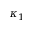<formula> <loc_0><loc_0><loc_500><loc_500>\kappa _ { 1 }</formula> 